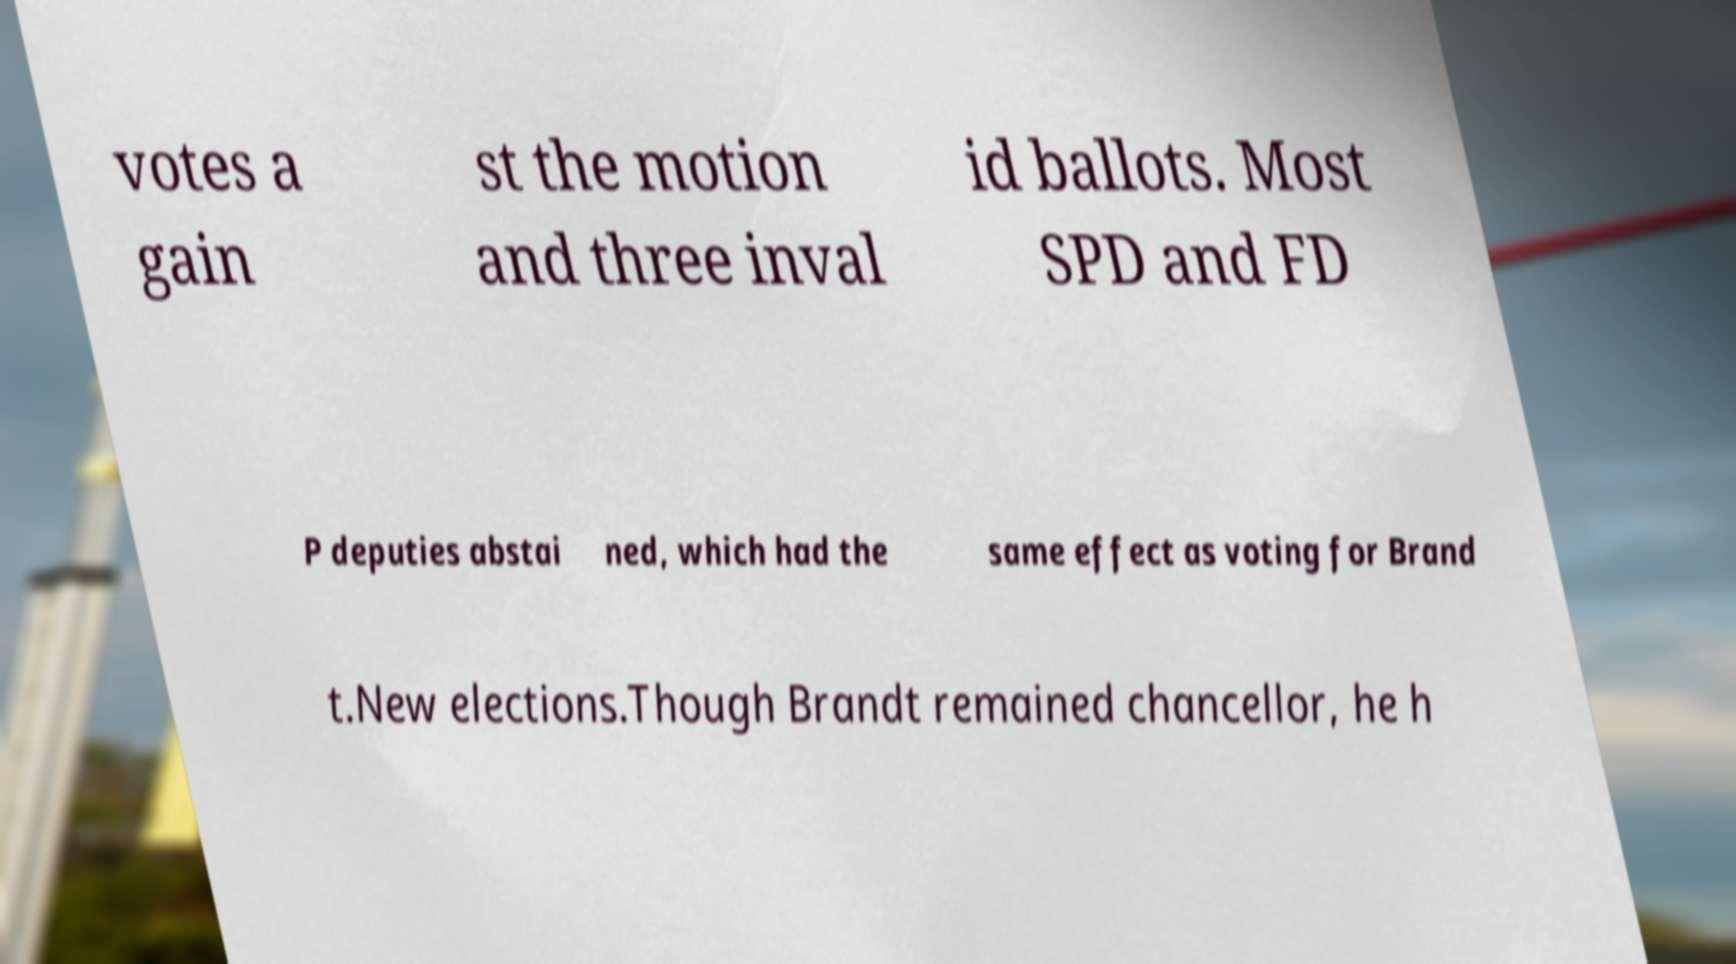Can you read and provide the text displayed in the image?This photo seems to have some interesting text. Can you extract and type it out for me? votes a gain st the motion and three inval id ballots. Most SPD and FD P deputies abstai ned, which had the same effect as voting for Brand t.New elections.Though Brandt remained chancellor, he h 